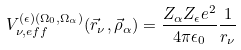<formula> <loc_0><loc_0><loc_500><loc_500>V _ { \nu , e f f } ^ { ( \epsilon ) ( \Omega _ { 0 } , \Omega _ { \alpha } ) } ( \vec { r } _ { \nu } , \vec { \rho } _ { \alpha } ) = \frac { Z _ { \alpha } Z _ { \epsilon } e ^ { 2 } } { 4 \pi \epsilon _ { 0 } } \frac { 1 } { r _ { \nu } }</formula> 